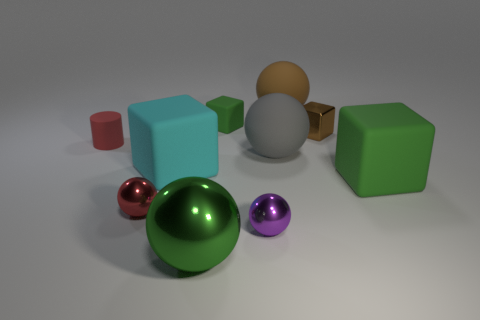Subtract 2 balls. How many balls are left? 3 Subtract all green spheres. How many spheres are left? 4 Subtract all gray matte balls. How many balls are left? 4 Subtract all gray balls. Subtract all green cubes. How many balls are left? 4 Subtract all cylinders. How many objects are left? 9 Subtract all brown shiny blocks. Subtract all cyan matte blocks. How many objects are left? 8 Add 4 large green balls. How many large green balls are left? 5 Add 3 large cyan cylinders. How many large cyan cylinders exist? 3 Subtract 1 cyan cubes. How many objects are left? 9 